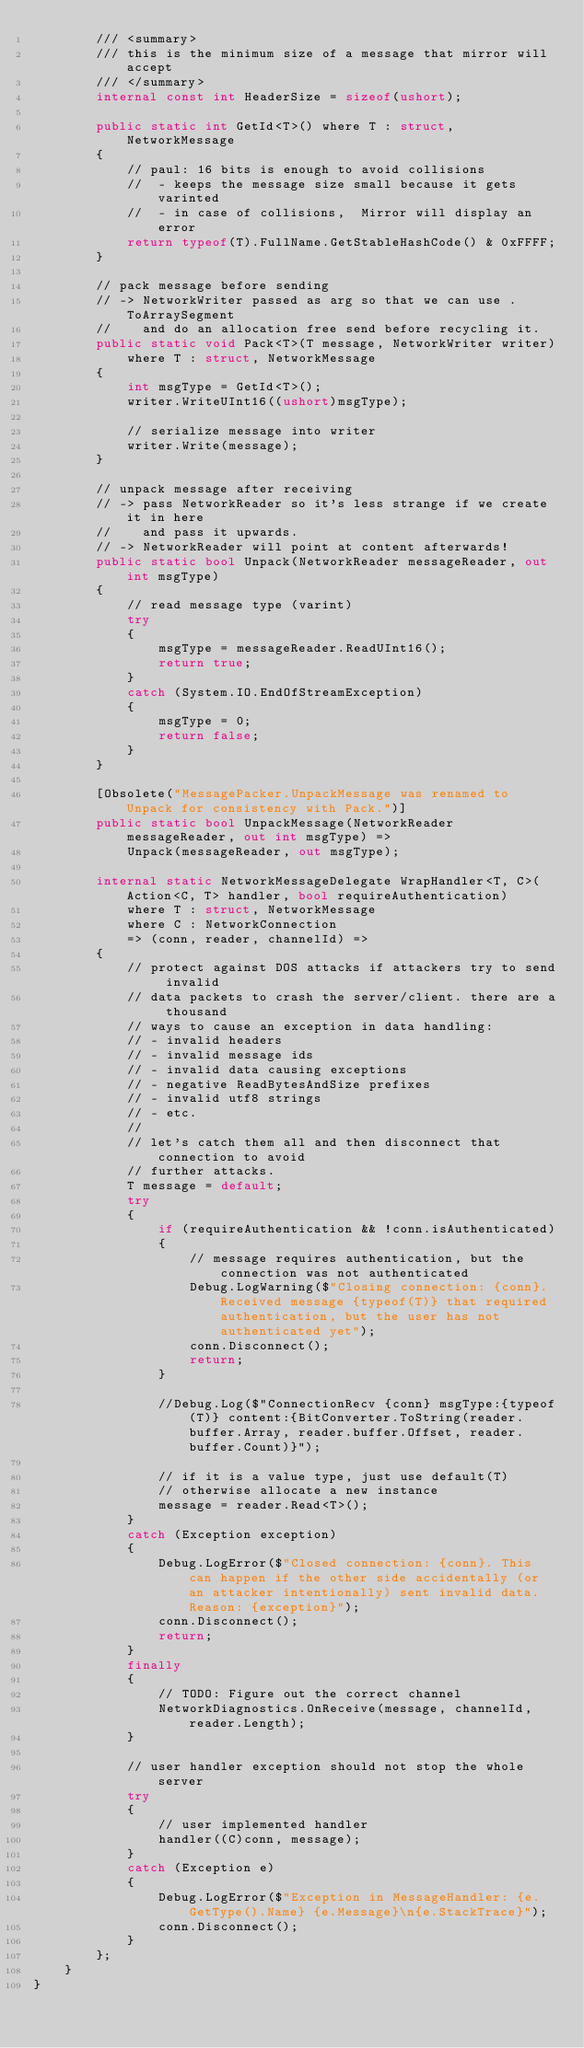<code> <loc_0><loc_0><loc_500><loc_500><_C#_>        /// <summary>
        /// this is the minimum size of a message that mirror will accept
        /// </summary>
        internal const int HeaderSize = sizeof(ushort);

        public static int GetId<T>() where T : struct, NetworkMessage
        {
            // paul: 16 bits is enough to avoid collisions
            //  - keeps the message size small because it gets varinted
            //  - in case of collisions,  Mirror will display an error
            return typeof(T).FullName.GetStableHashCode() & 0xFFFF;
        }

        // pack message before sending
        // -> NetworkWriter passed as arg so that we can use .ToArraySegment
        //    and do an allocation free send before recycling it.
        public static void Pack<T>(T message, NetworkWriter writer)
            where T : struct, NetworkMessage
        {
            int msgType = GetId<T>();
            writer.WriteUInt16((ushort)msgType);

            // serialize message into writer
            writer.Write(message);
        }

        // unpack message after receiving
        // -> pass NetworkReader so it's less strange if we create it in here
        //    and pass it upwards.
        // -> NetworkReader will point at content afterwards!
        public static bool Unpack(NetworkReader messageReader, out int msgType)
        {
            // read message type (varint)
            try
            {
                msgType = messageReader.ReadUInt16();
                return true;
            }
            catch (System.IO.EndOfStreamException)
            {
                msgType = 0;
                return false;
            }
        }

        [Obsolete("MessagePacker.UnpackMessage was renamed to Unpack for consistency with Pack.")]
        public static bool UnpackMessage(NetworkReader messageReader, out int msgType) =>
            Unpack(messageReader, out msgType);

        internal static NetworkMessageDelegate WrapHandler<T, C>(Action<C, T> handler, bool requireAuthentication)
            where T : struct, NetworkMessage
            where C : NetworkConnection
            => (conn, reader, channelId) =>
        {
            // protect against DOS attacks if attackers try to send invalid
            // data packets to crash the server/client. there are a thousand
            // ways to cause an exception in data handling:
            // - invalid headers
            // - invalid message ids
            // - invalid data causing exceptions
            // - negative ReadBytesAndSize prefixes
            // - invalid utf8 strings
            // - etc.
            //
            // let's catch them all and then disconnect that connection to avoid
            // further attacks.
            T message = default;
            try
            {
                if (requireAuthentication && !conn.isAuthenticated)
                {
                    // message requires authentication, but the connection was not authenticated
                    Debug.LogWarning($"Closing connection: {conn}. Received message {typeof(T)} that required authentication, but the user has not authenticated yet");
                    conn.Disconnect();
                    return;
                }

                //Debug.Log($"ConnectionRecv {conn} msgType:{typeof(T)} content:{BitConverter.ToString(reader.buffer.Array, reader.buffer.Offset, reader.buffer.Count)}");

                // if it is a value type, just use default(T)
                // otherwise allocate a new instance
                message = reader.Read<T>();
            }
            catch (Exception exception)
            {
                Debug.LogError($"Closed connection: {conn}. This can happen if the other side accidentally (or an attacker intentionally) sent invalid data. Reason: {exception}");
                conn.Disconnect();
                return;
            }
            finally
            {
                // TODO: Figure out the correct channel
                NetworkDiagnostics.OnReceive(message, channelId, reader.Length);
            }

            // user handler exception should not stop the whole server
            try
            {
                // user implemented handler
                handler((C)conn, message);
            }
            catch (Exception e)
            {
                Debug.LogError($"Exception in MessageHandler: {e.GetType().Name} {e.Message}\n{e.StackTrace}");
                conn.Disconnect();
            }
        };
    }
}
</code> 